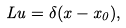<formula> <loc_0><loc_0><loc_500><loc_500>L u = \delta ( x - x _ { 0 } ) ,</formula> 